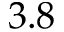Convert formula to latex. <formula><loc_0><loc_0><loc_500><loc_500>3 . 8</formula> 